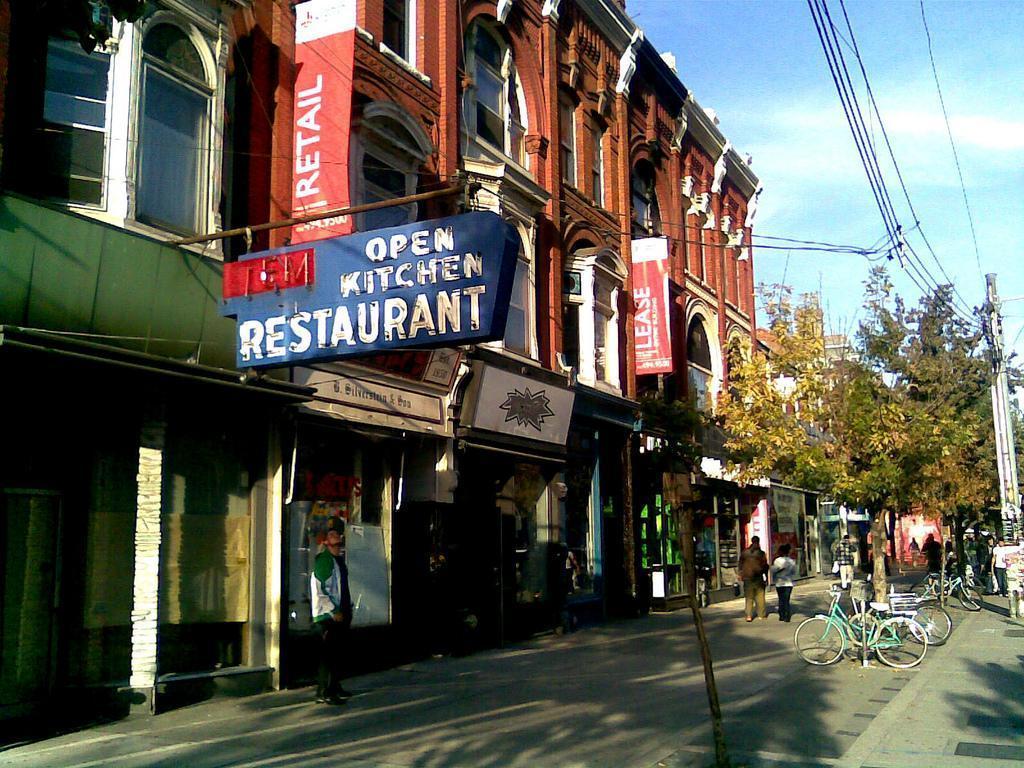How many green bikes are in the picture?
Give a very brief answer. 2. 